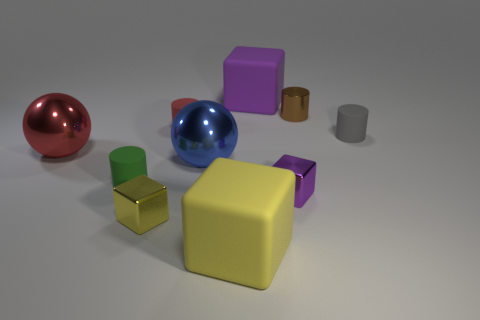What is the material of the large yellow thing?
Your answer should be compact. Rubber. There is a cube on the left side of the large matte object left of the large purple cube; how many tiny things are on the right side of it?
Your answer should be very brief. 4. There is a thing to the left of the green cylinder in front of the blue sphere; what size is it?
Your answer should be very brief. Large. What size is the blue object that is made of the same material as the tiny brown cylinder?
Provide a succinct answer. Large. What is the shape of the matte thing that is both right of the tiny red rubber object and behind the gray rubber cylinder?
Offer a very short reply. Cube. Are there the same number of large blue metal objects that are to the left of the big red thing and yellow metallic objects?
Provide a short and direct response. No. How many things are big shiny spheres or big rubber blocks behind the tiny brown thing?
Your answer should be very brief. 3. Are there any other big things that have the same shape as the blue thing?
Offer a terse response. Yes. Are there an equal number of red shiny objects on the right side of the big purple matte thing and small rubber things that are right of the green cylinder?
Give a very brief answer. No. Is there anything else that is the same size as the gray thing?
Provide a succinct answer. Yes. 